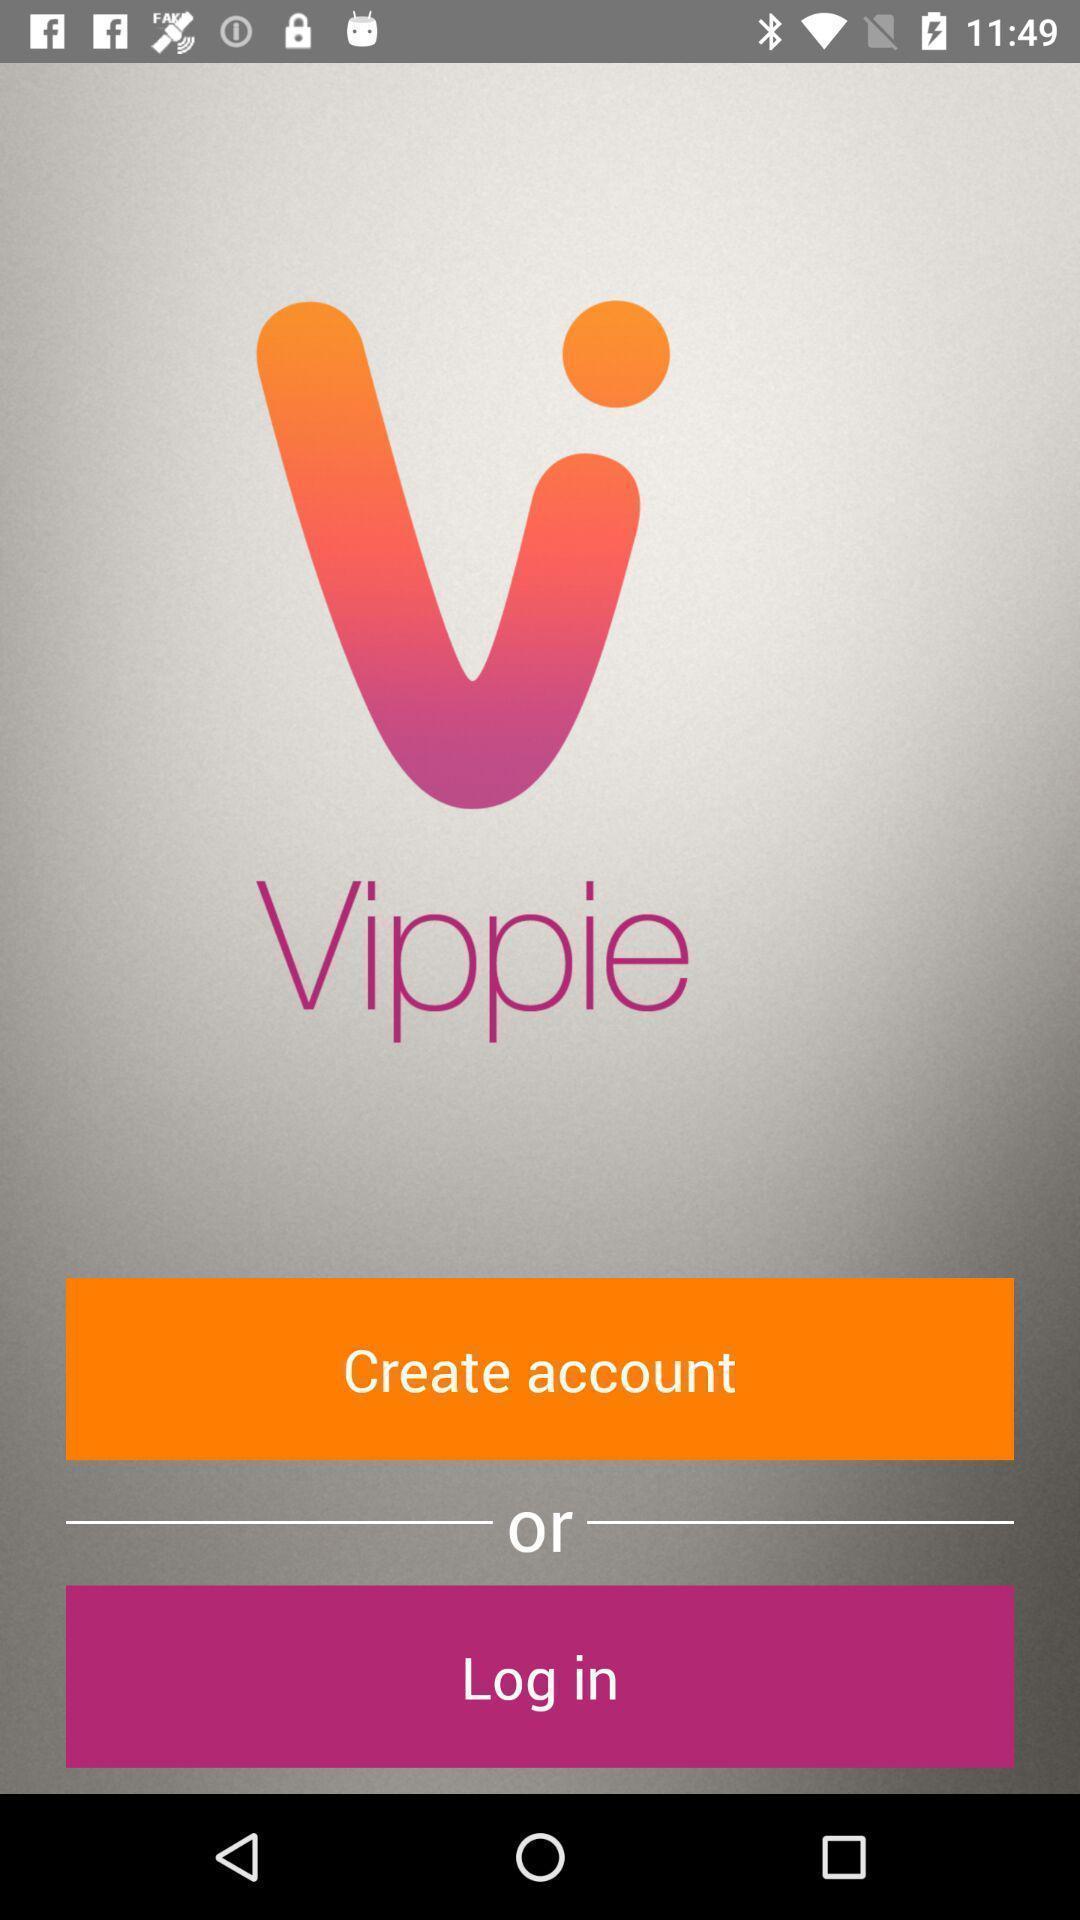Please provide a description for this image. Screen displaying the login page. 